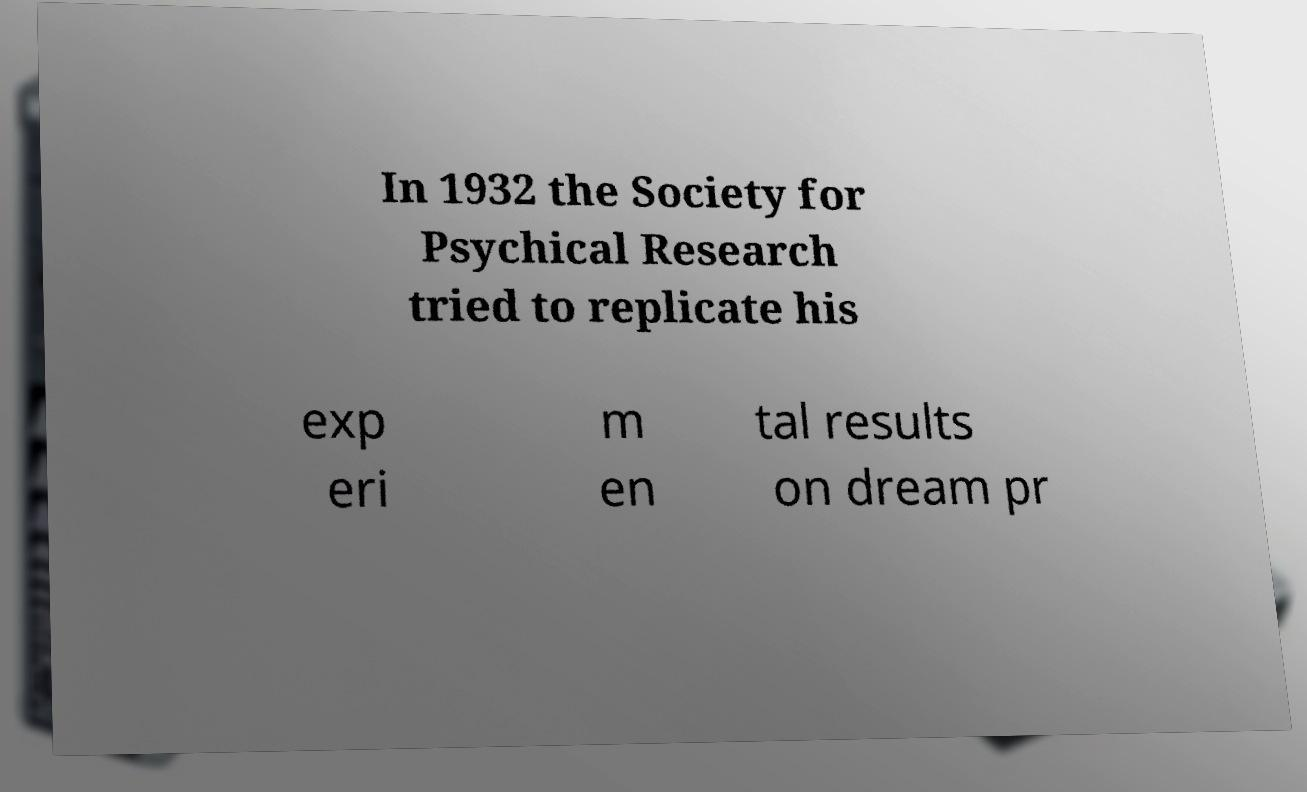For documentation purposes, I need the text within this image transcribed. Could you provide that? In 1932 the Society for Psychical Research tried to replicate his exp eri m en tal results on dream pr 